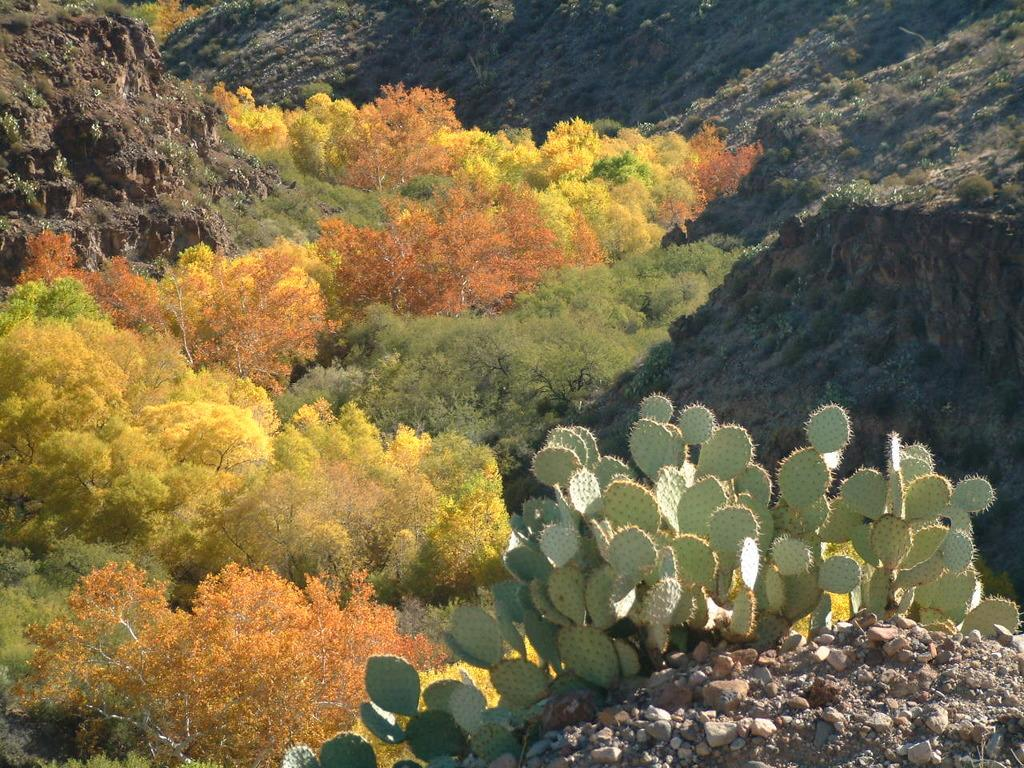What type of plants are in the image? There are desert plants in the image. What can be seen in the background of the image? There are trees and mountains in the background of the image. How many records can be seen on the desert plants in the image? There are no records present in the image, as it features desert plants and a background with trees and mountains. 